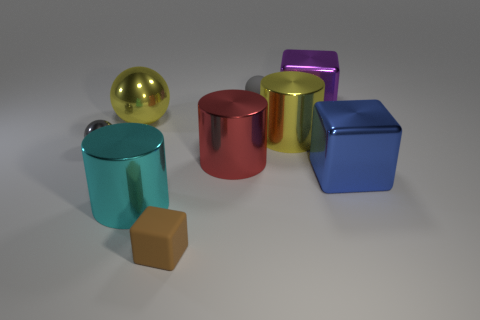Does the brown object have the same shape as the big purple object?
Provide a succinct answer. Yes. What size is the yellow shiny object that is to the left of the large metallic cylinder to the left of the small object in front of the large blue metallic cube?
Your answer should be compact. Large. There is a tiny brown object that is the same shape as the purple object; what material is it?
Your answer should be compact. Rubber. There is a metallic cube on the left side of the big metal block that is in front of the purple shiny thing; what size is it?
Your answer should be compact. Large. What color is the big metallic sphere?
Offer a very short reply. Yellow. What number of matte things are behind the metallic cylinder that is behind the red thing?
Make the answer very short. 1. Is there a small sphere behind the cylinder that is in front of the red metallic thing?
Make the answer very short. Yes. Are there any large objects right of the tiny gray rubber ball?
Offer a terse response. Yes. Does the matte object that is behind the gray metallic thing have the same shape as the gray metal thing?
Keep it short and to the point. Yes. How many other shiny things have the same shape as the red shiny thing?
Keep it short and to the point. 2. 